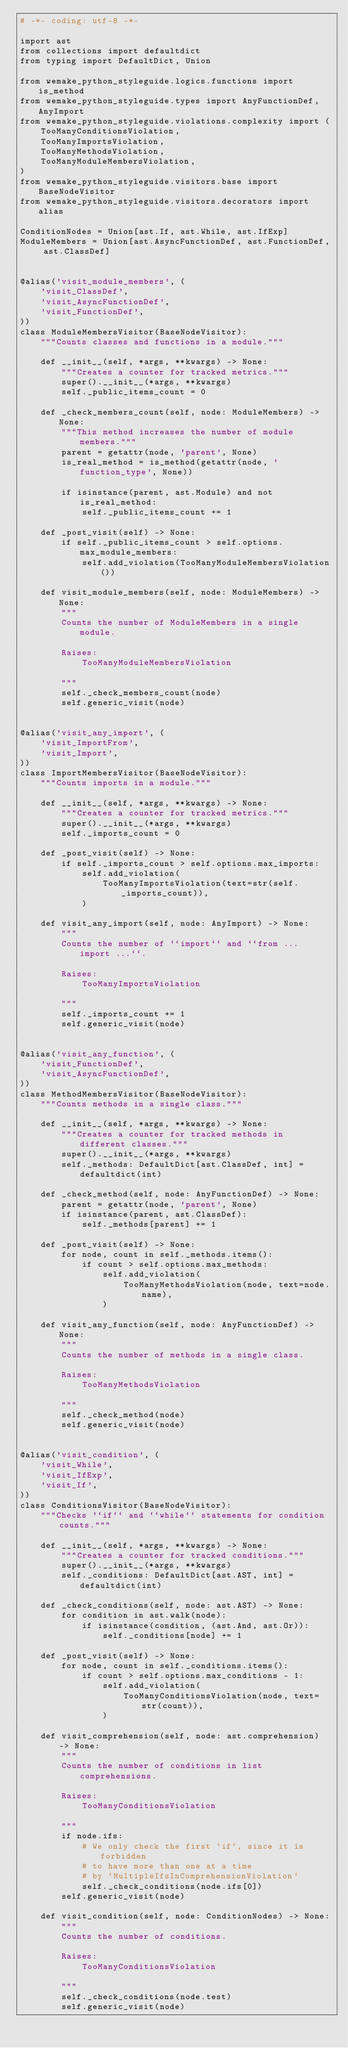Convert code to text. <code><loc_0><loc_0><loc_500><loc_500><_Python_># -*- coding: utf-8 -*-

import ast
from collections import defaultdict
from typing import DefaultDict, Union

from wemake_python_styleguide.logics.functions import is_method
from wemake_python_styleguide.types import AnyFunctionDef, AnyImport
from wemake_python_styleguide.violations.complexity import (
    TooManyConditionsViolation,
    TooManyImportsViolation,
    TooManyMethodsViolation,
    TooManyModuleMembersViolation,
)
from wemake_python_styleguide.visitors.base import BaseNodeVisitor
from wemake_python_styleguide.visitors.decorators import alias

ConditionNodes = Union[ast.If, ast.While, ast.IfExp]
ModuleMembers = Union[ast.AsyncFunctionDef, ast.FunctionDef, ast.ClassDef]


@alias('visit_module_members', (
    'visit_ClassDef',
    'visit_AsyncFunctionDef',
    'visit_FunctionDef',
))
class ModuleMembersVisitor(BaseNodeVisitor):
    """Counts classes and functions in a module."""

    def __init__(self, *args, **kwargs) -> None:
        """Creates a counter for tracked metrics."""
        super().__init__(*args, **kwargs)
        self._public_items_count = 0

    def _check_members_count(self, node: ModuleMembers) -> None:
        """This method increases the number of module members."""
        parent = getattr(node, 'parent', None)
        is_real_method = is_method(getattr(node, 'function_type', None))

        if isinstance(parent, ast.Module) and not is_real_method:
            self._public_items_count += 1

    def _post_visit(self) -> None:
        if self._public_items_count > self.options.max_module_members:
            self.add_violation(TooManyModuleMembersViolation())

    def visit_module_members(self, node: ModuleMembers) -> None:
        """
        Counts the number of ModuleMembers in a single module.

        Raises:
            TooManyModuleMembersViolation

        """
        self._check_members_count(node)
        self.generic_visit(node)


@alias('visit_any_import', (
    'visit_ImportFrom',
    'visit_Import',
))
class ImportMembersVisitor(BaseNodeVisitor):
    """Counts imports in a module."""

    def __init__(self, *args, **kwargs) -> None:
        """Creates a counter for tracked metrics."""
        super().__init__(*args, **kwargs)
        self._imports_count = 0

    def _post_visit(self) -> None:
        if self._imports_count > self.options.max_imports:
            self.add_violation(
                TooManyImportsViolation(text=str(self._imports_count)),
            )

    def visit_any_import(self, node: AnyImport) -> None:
        """
        Counts the number of ``import`` and ``from ... import ...``.

        Raises:
            TooManyImportsViolation

        """
        self._imports_count += 1
        self.generic_visit(node)


@alias('visit_any_function', (
    'visit_FunctionDef',
    'visit_AsyncFunctionDef',
))
class MethodMembersVisitor(BaseNodeVisitor):
    """Counts methods in a single class."""

    def __init__(self, *args, **kwargs) -> None:
        """Creates a counter for tracked methods in different classes."""
        super().__init__(*args, **kwargs)
        self._methods: DefaultDict[ast.ClassDef, int] = defaultdict(int)

    def _check_method(self, node: AnyFunctionDef) -> None:
        parent = getattr(node, 'parent', None)
        if isinstance(parent, ast.ClassDef):
            self._methods[parent] += 1

    def _post_visit(self) -> None:
        for node, count in self._methods.items():
            if count > self.options.max_methods:
                self.add_violation(
                    TooManyMethodsViolation(node, text=node.name),
                )

    def visit_any_function(self, node: AnyFunctionDef) -> None:
        """
        Counts the number of methods in a single class.

        Raises:
            TooManyMethodsViolation

        """
        self._check_method(node)
        self.generic_visit(node)


@alias('visit_condition', (
    'visit_While',
    'visit_IfExp',
    'visit_If',
))
class ConditionsVisitor(BaseNodeVisitor):
    """Checks ``if`` and ``while`` statements for condition counts."""

    def __init__(self, *args, **kwargs) -> None:
        """Creates a counter for tracked conditions."""
        super().__init__(*args, **kwargs)
        self._conditions: DefaultDict[ast.AST, int] = defaultdict(int)

    def _check_conditions(self, node: ast.AST) -> None:
        for condition in ast.walk(node):
            if isinstance(condition, (ast.And, ast.Or)):
                self._conditions[node] += 1

    def _post_visit(self) -> None:
        for node, count in self._conditions.items():
            if count > self.options.max_conditions - 1:
                self.add_violation(
                    TooManyConditionsViolation(node, text=str(count)),
                )

    def visit_comprehension(self, node: ast.comprehension) -> None:
        """
        Counts the number of conditions in list comprehensions.

        Raises:
            TooManyConditionsViolation

        """
        if node.ifs:
            # We only check the first `if`, since it is forbidden
            # to have more than one at a time
            # by `MultipleIfsInComprehensionViolation`
            self._check_conditions(node.ifs[0])
        self.generic_visit(node)

    def visit_condition(self, node: ConditionNodes) -> None:
        """
        Counts the number of conditions.

        Raises:
            TooManyConditionsViolation

        """
        self._check_conditions(node.test)
        self.generic_visit(node)
</code> 